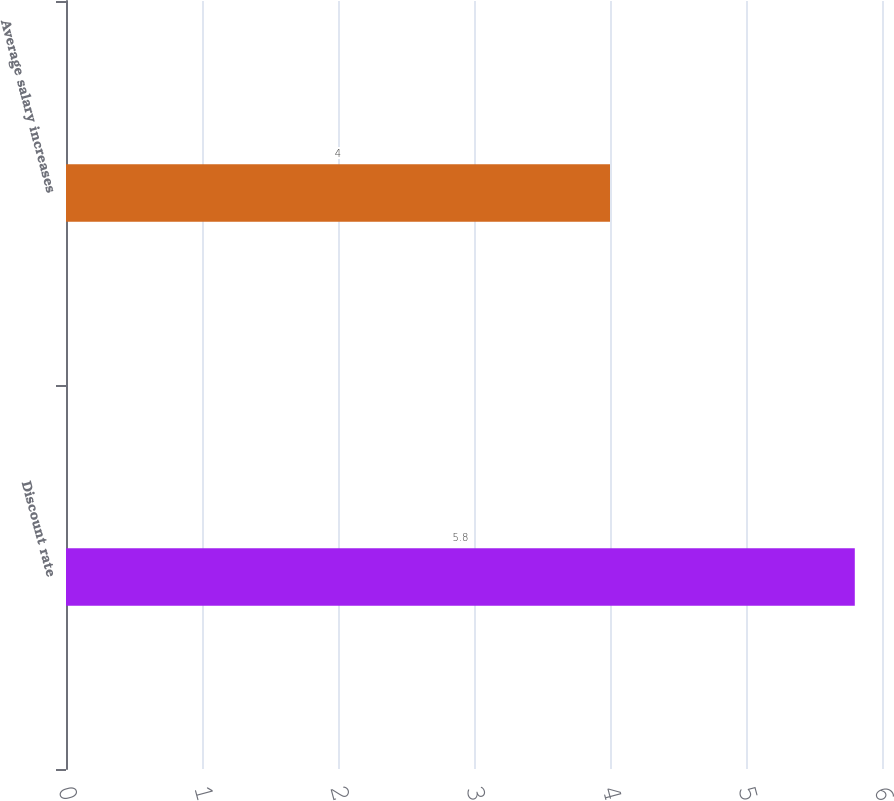Convert chart. <chart><loc_0><loc_0><loc_500><loc_500><bar_chart><fcel>Discount rate<fcel>Average salary increases<nl><fcel>5.8<fcel>4<nl></chart> 